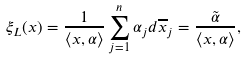<formula> <loc_0><loc_0><loc_500><loc_500>\xi _ { L } ( x ) = \frac { 1 } { \langle x , \alpha \rangle } \sum _ { j = 1 } ^ { n } \alpha _ { j } d \overline { x } _ { j } = \frac { \tilde { \alpha } } { \langle x , \alpha \rangle } ,</formula> 